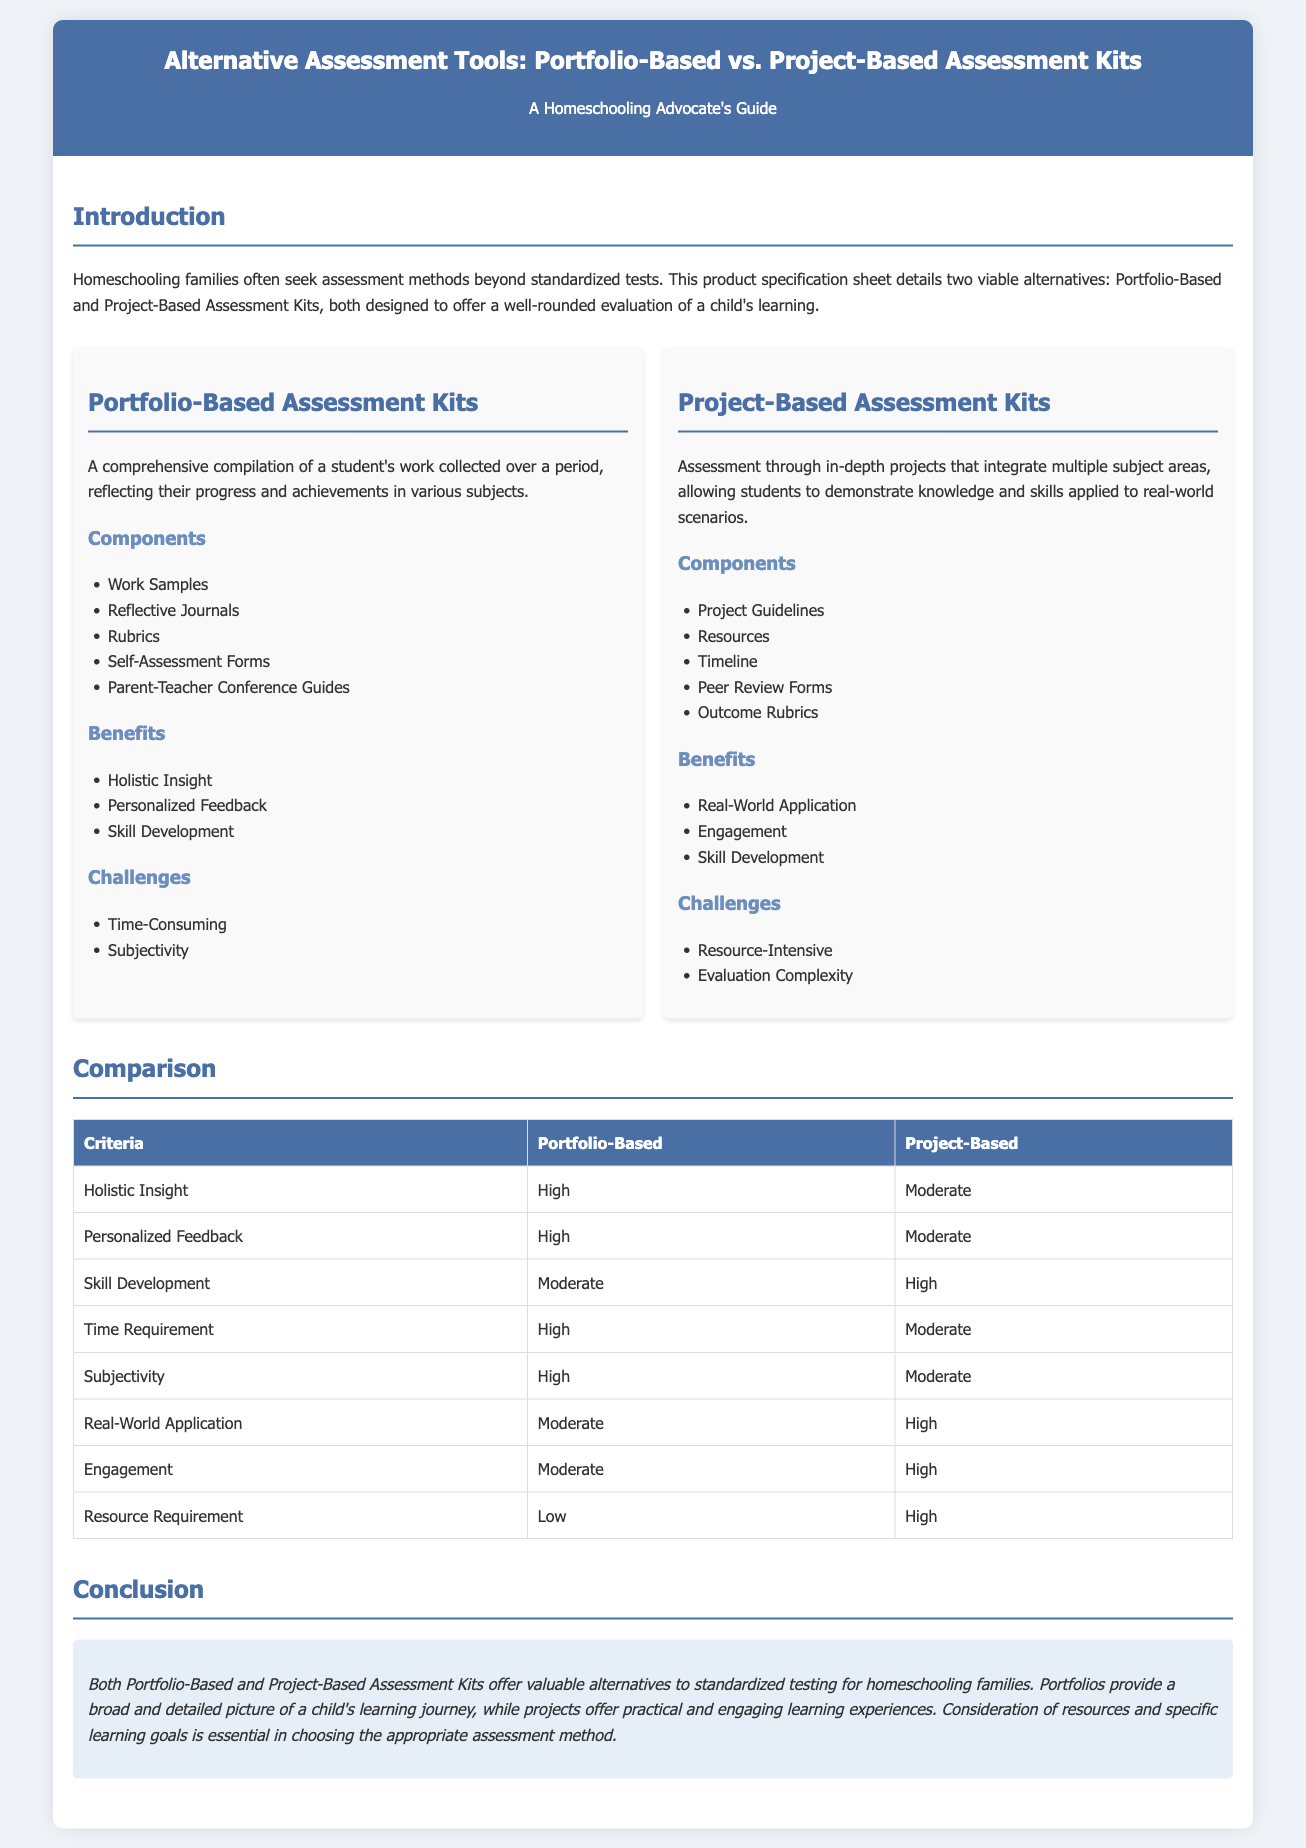What are the components of Portfolio-Based Assessment Kits? The document lists several components in the relevant section, including Work Samples, Reflective Journals, Rubrics, Self-Assessment Forms, and Parent-Teacher Conference Guides.
Answer: Work Samples, Reflective Journals, Rubrics, Self-Assessment Forms, Parent-Teacher Conference Guides What is a significant benefit of Project-Based Assessment Kits? The document indicates that one of the benefits of Project-Based Assessment Kits is real-world application, hence it can be considered significant.
Answer: Real-World Application What is the primary challenge of Portfolio-Based Assessment? The document mentions subjectivity as a challenge in the Portfolio-Based Assessment Kits section.
Answer: Subjectivity What level of engagement is associated with Project-Based Assessment? The comparison table in the document specifies that the engagement level is high for Project-Based assessments.
Answer: High How does Portfolio-Based Assessment rank in terms of holistic insight? According to the comparison table, it ranks high for holistic insight.
Answer: High What is the necessary time requirement for Portfolio-Based Assessment Kits? The comparison table presents a high time requirement for Portfolio-Based Assessment Kits.
Answer: High Which assessment type provides more personalized feedback? The information in the document suggests that Portfolio-Based Assessment provides high personalized feedback compared to Project-Based Assessment.
Answer: Portfolio-Based What overall conclusion is drawn about Portfolio-Based and Project-Based Assessment Kits? The conclusion section summarizes that both assessment types offer valuable alternatives to standardized testing, giving a broad and detailed picture versus practical and engaging experiences.
Answer: Valuable alternatives to standardized testing 